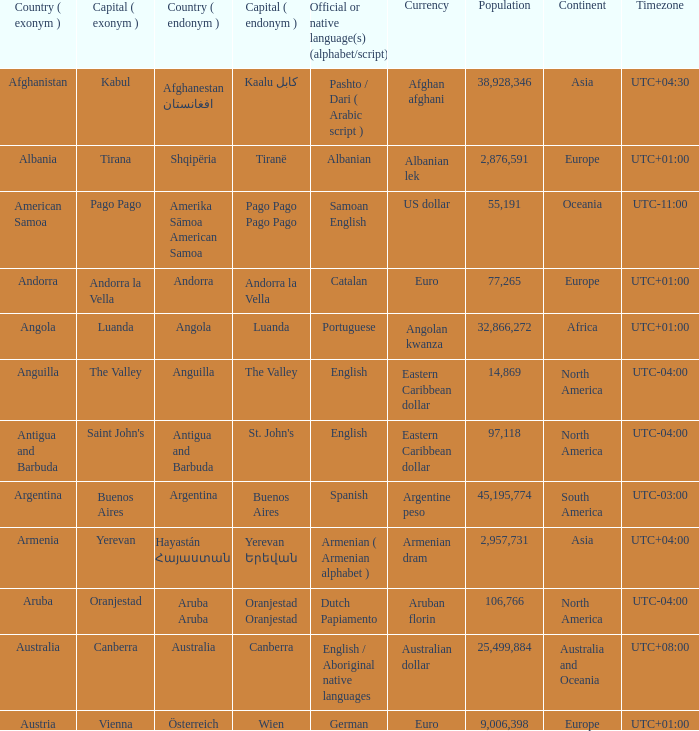What official or native languages are spoken in the country whose capital city is Canberra? English / Aboriginal native languages. 